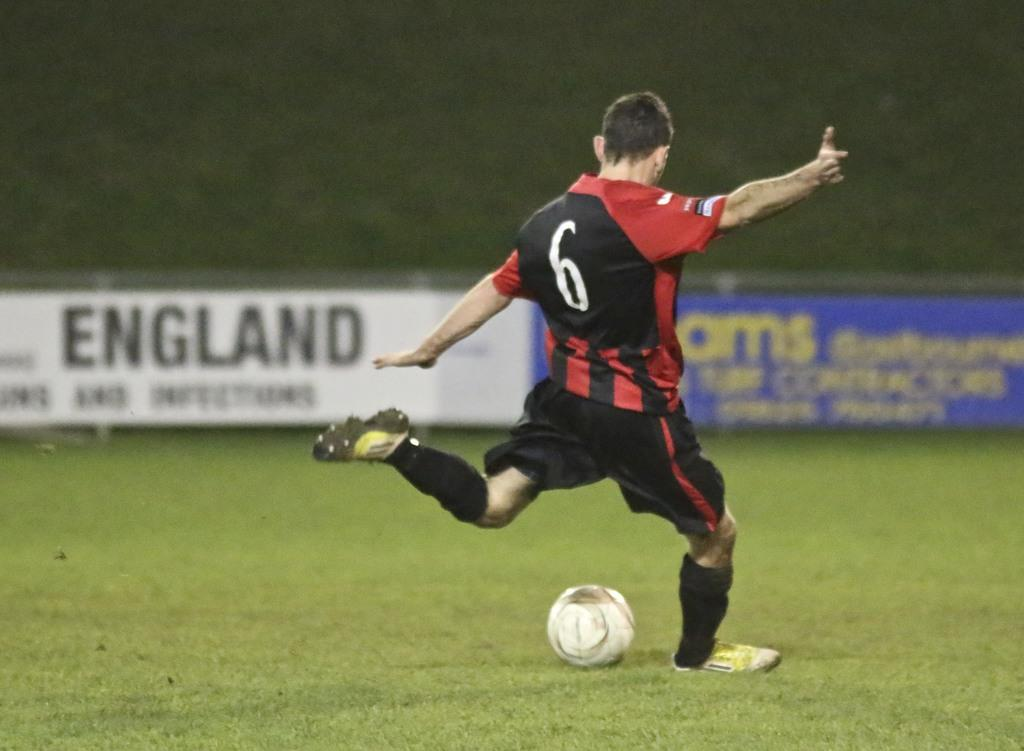<image>
Summarize the visual content of the image. Soccer player number 6 kicks a ball on a field. 